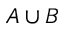Convert formula to latex. <formula><loc_0><loc_0><loc_500><loc_500>A \cup B</formula> 